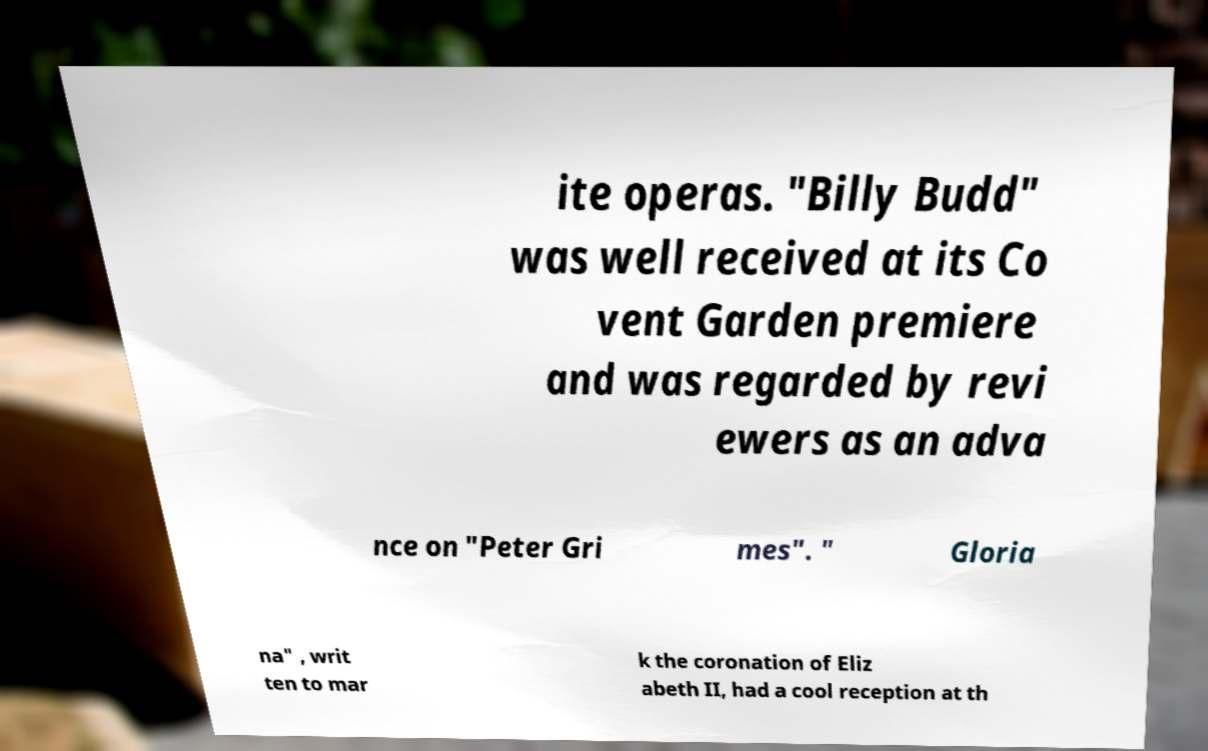What messages or text are displayed in this image? I need them in a readable, typed format. ite operas. "Billy Budd" was well received at its Co vent Garden premiere and was regarded by revi ewers as an adva nce on "Peter Gri mes". " Gloria na" , writ ten to mar k the coronation of Eliz abeth II, had a cool reception at th 